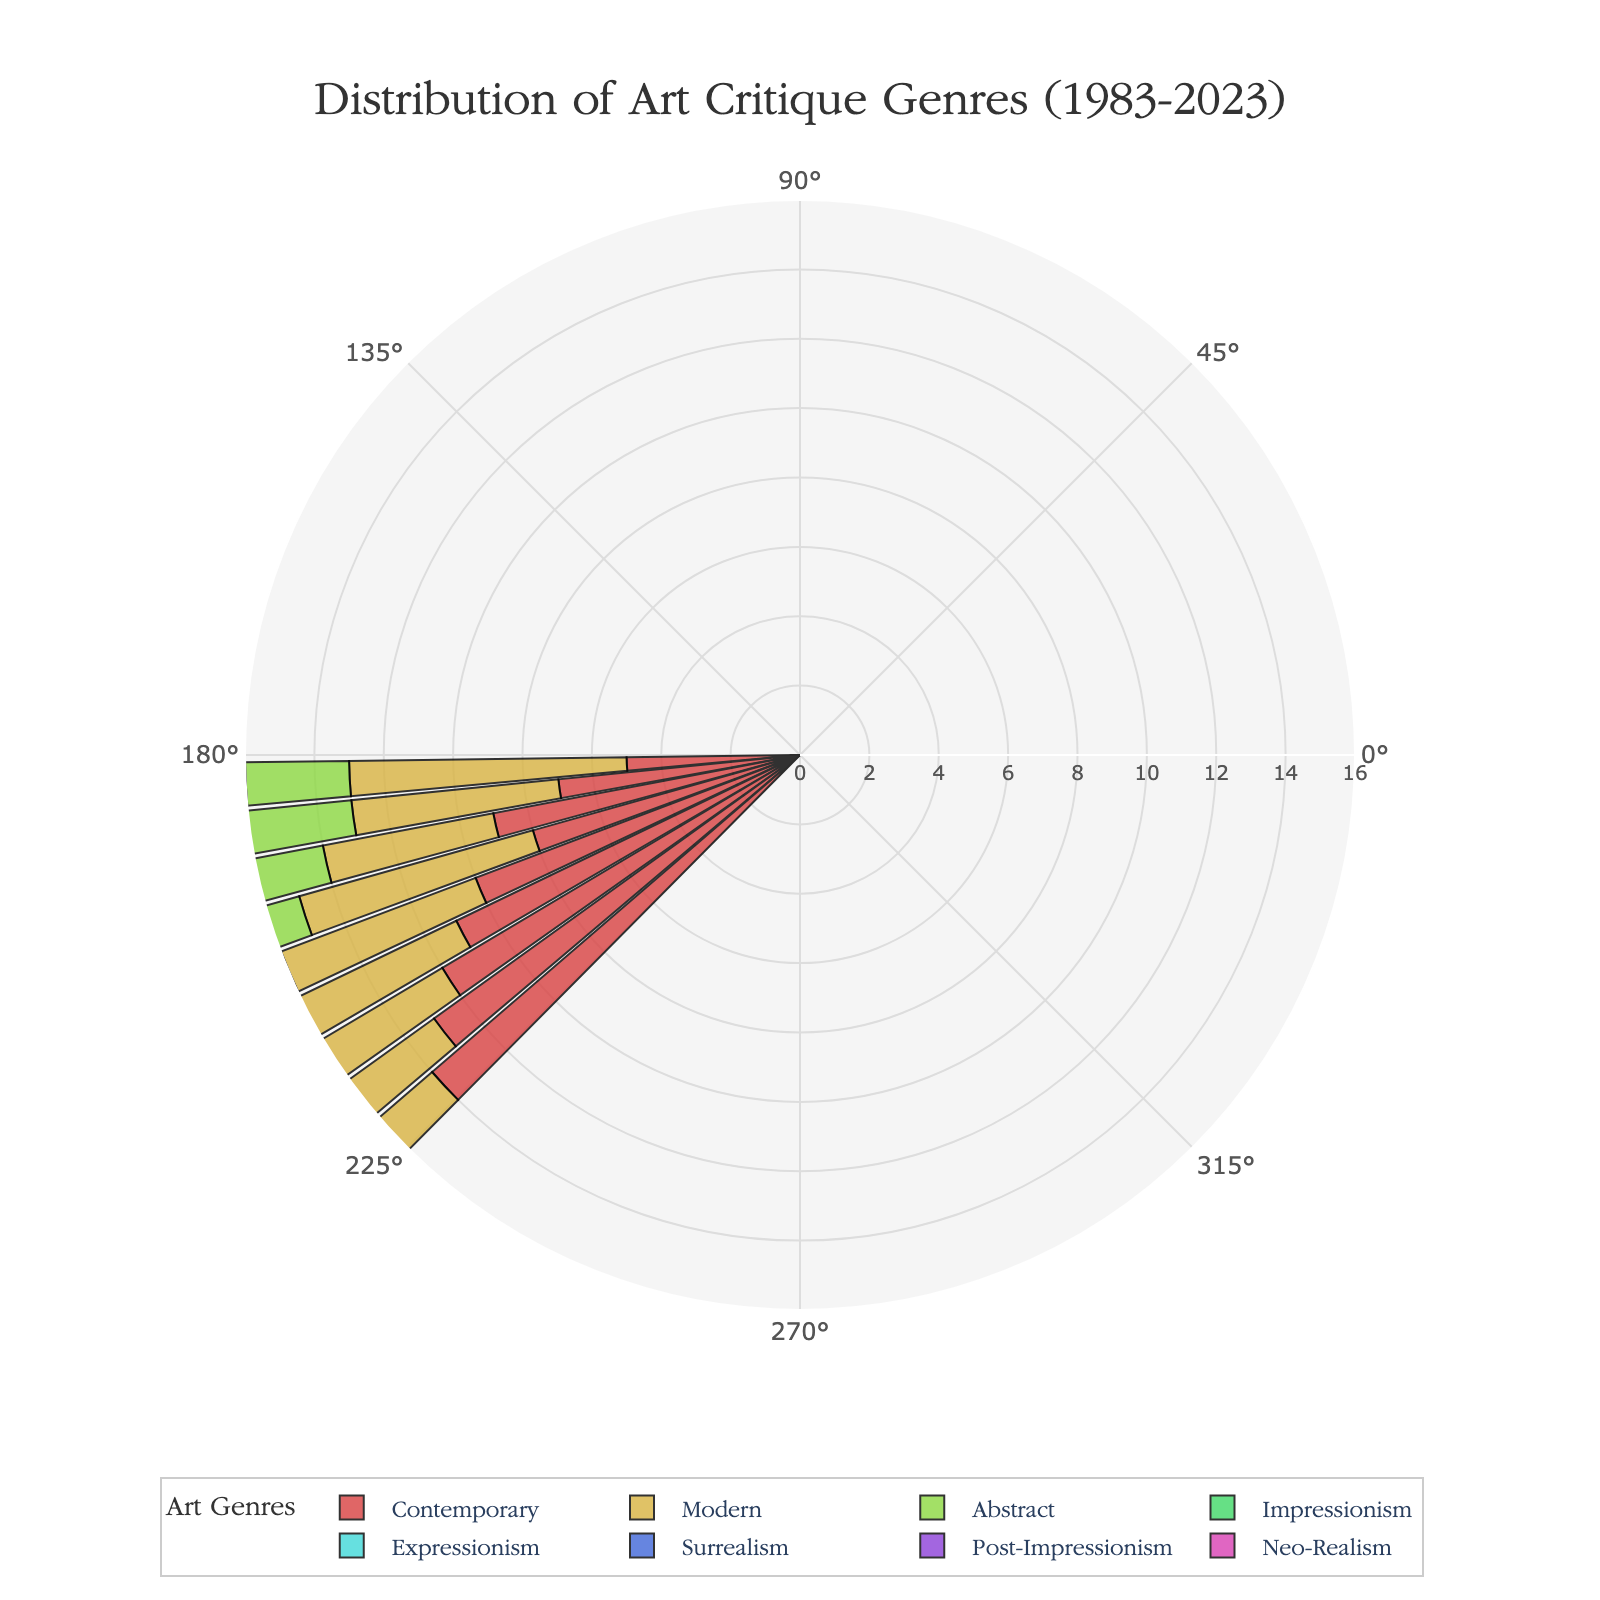What is the title of the rose chart? The title is usually located at the top center of the chart. It indicates the subject and time period represented.
Answer: Distribution of Art Critique Genres (1983-2023) How many genres of art critiques are displayed? By observing the legend or the colored segments of the chart, we can count the distinct categories.
Answer: 8 Which art critique genre has shown the most significant increase from 1983 to 2023? Compare the values of each genre from 1983 and 2023 by looking at the differences visually or by noting the numbers. The genre with the largest increase is the answer.
Answer: Contemporary What is the maximum value represented on the radial axis? The value on the radial axis can be found by looking at the highest value marked on the circular grid lines.
Answer: 16 How does the popularity of Abstract critiques change over the years? Track the segment corresponding to Abstract critiques across different years and observe the trend in size. This genre starts at 3 in 1983 and peaks at 9 in 2023.
Answer: It increases gradually Which years have the highest and lowest counts of Surrealism critiques? Identify the values of Surrealism critiques by the segment size for each year and compare them to determine the extremes.
Answer: 2023 (highest) and 1983 (lowest) In which year did Contemporary critiques surpass 10? Trace the size of the Contemporary critique segment and pinpoint the year when it first exceeds 10.
Answer: 2003 What is the difference between the counts of Modern critiques in 1983 and 2023? Subtract the 1983 value of Modern critiques from the 2023 value to get the difference (8 - 4).
Answer: 4 How do Impressionism critiques in 1983 compare to those in 2023? Examine the segment for Impressionism in both years and compare their sizes. Both years have a similar count, so check the exact numbers.
Answer: They have the same count (both 2) What's the average number of Expressionism critiques from 1983 to 2023? Add up the counts of Expressionism critiques for all years and divide by the number of years (9) to find the average. (2+1+3+2+3+4+3+4+3)/9 ≈ 2.78
Answer: Approximately 2.78 